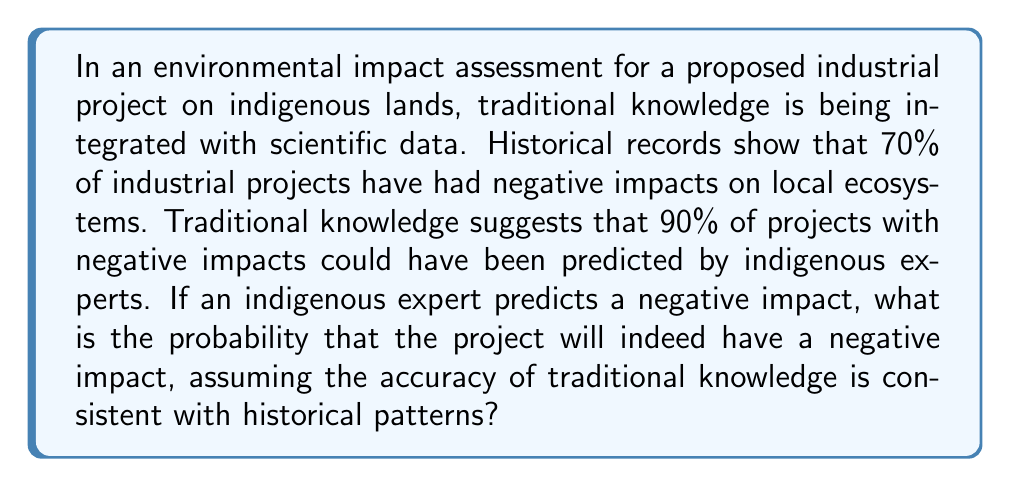Provide a solution to this math problem. To solve this problem, we'll use Bayes' theorem. Let's define our events:

A: The project has a negative impact
B: An indigenous expert predicts a negative impact

Given:
P(A) = 0.70 (probability of negative impact based on historical data)
P(B|A) = 0.90 (probability of prediction given a negative impact)

We need to find P(A|B) (probability of negative impact given a prediction)

Bayes' theorem states:

$$P(A|B) = \frac{P(B|A) \cdot P(A)}{P(B)}$$

We know P(B|A) and P(A), but we need to calculate P(B):

$$P(B) = P(B|A) \cdot P(A) + P(B|\text{not }A) \cdot P(\text{not }A)$$

We don't know P(B|not A), but we can assume it's low. Let's estimate it at 0.10.

P(not A) = 1 - P(A) = 1 - 0.70 = 0.30

Now we can calculate P(B):

$$P(B) = 0.90 \cdot 0.70 + 0.10 \cdot 0.30 = 0.63 + 0.03 = 0.66$$

Plugging everything into Bayes' theorem:

$$P(A|B) = \frac{0.90 \cdot 0.70}{0.66} \approx 0.9545$$

Therefore, the probability that the project will have a negative impact, given that an indigenous expert predicts it, is approximately 0.9545 or 95.45%.
Answer: 0.9545 (or 95.45%) 